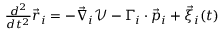<formula> <loc_0><loc_0><loc_500><loc_500>\begin{array} { r } { \frac { d ^ { 2 } } { d t ^ { 2 } } \vec { r } _ { i } = - \vec { \nabla } _ { i } \mathcal { V } - \Gamma _ { i } \cdot \vec { p } _ { i } + \vec { \xi } _ { i } ( t ) } \end{array}</formula> 